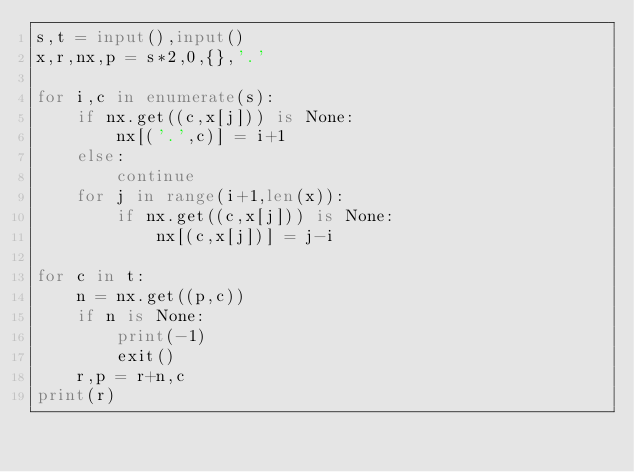<code> <loc_0><loc_0><loc_500><loc_500><_Python_>s,t = input(),input()
x,r,nx,p = s*2,0,{},'.'

for i,c in enumerate(s):
	if nx.get((c,x[j])) is None:
		nx[('.',c)] = i+1
	else:
		continue
	for j in range(i+1,len(x)):
		if nx.get((c,x[j])) is None:
			nx[(c,x[j])] = j-i

for c in t:
	n = nx.get((p,c))
	if n is None:
		print(-1)
		exit()
	r,p = r+n,c
print(r)</code> 